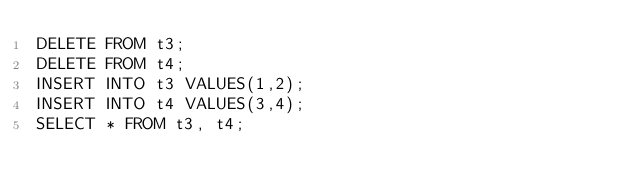Convert code to text. <code><loc_0><loc_0><loc_500><loc_500><_SQL_>DELETE FROM t3;
DELETE FROM t4;
INSERT INTO t3 VALUES(1,2);
INSERT INTO t4 VALUES(3,4);
SELECT * FROM t3, t4;</code> 